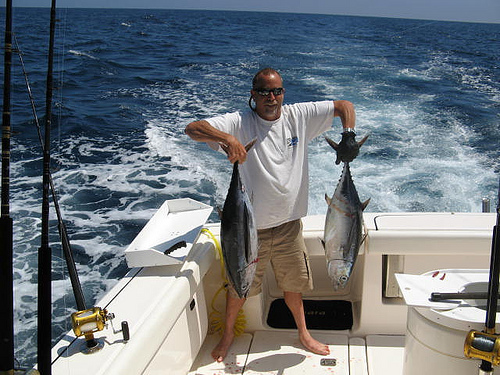<image>
Can you confirm if the fish is behind the ocean? No. The fish is not behind the ocean. From this viewpoint, the fish appears to be positioned elsewhere in the scene. 